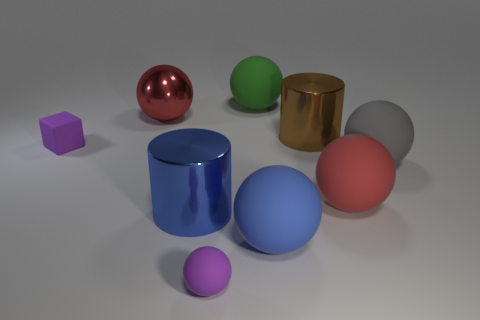Subtract all big gray balls. How many balls are left? 5 Subtract all green balls. How many balls are left? 5 Subtract all balls. How many objects are left? 3 Subtract all yellow cylinders. How many red balls are left? 2 Subtract 1 purple cubes. How many objects are left? 8 Subtract 1 spheres. How many spheres are left? 5 Subtract all yellow balls. Subtract all cyan cylinders. How many balls are left? 6 Subtract all big cyan matte balls. Subtract all tiny purple rubber things. How many objects are left? 7 Add 9 tiny purple matte blocks. How many tiny purple matte blocks are left? 10 Add 2 large blue rubber things. How many large blue rubber things exist? 3 